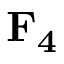<formula> <loc_0><loc_0><loc_500><loc_500>F _ { 4 }</formula> 